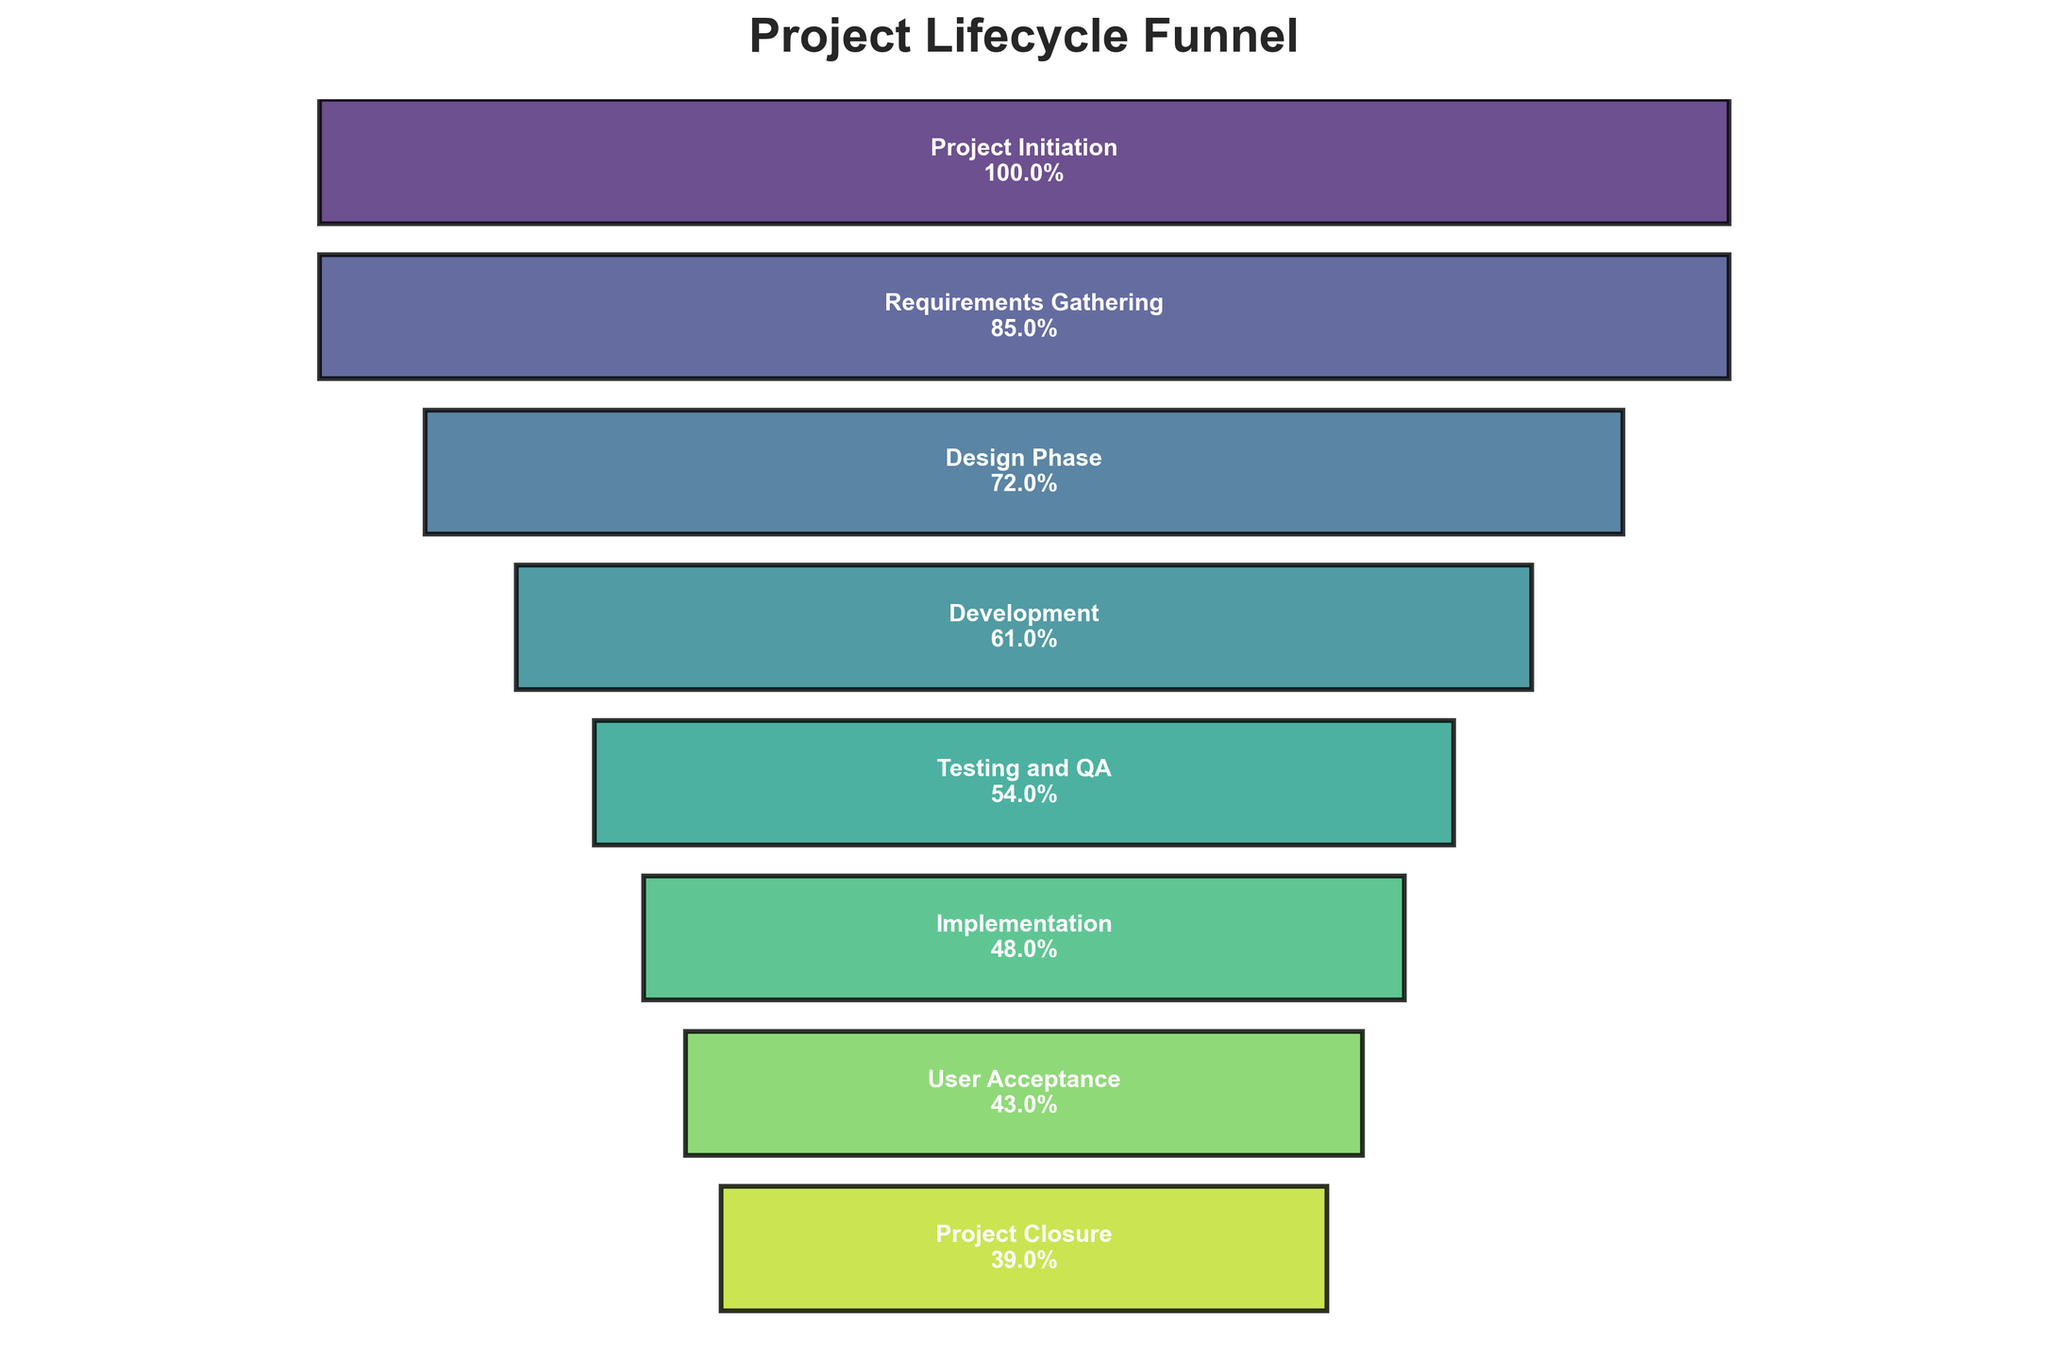How many stages are detailed in the Funnel Chart? The Funnel Chart has labels for each stage of the project lifecycle from initiation to closure. Counting these labels gives the total number of stages.
Answer: 8 What is the first stage in the project lifecycle? The Funnel Chart lists the stages from top to bottom. The first stage is at the top of the chart.
Answer: Project Initiation What's the difference in conversion rates between the 'Design Phase' and 'Development'? To find the difference, subtract the conversion rate of 'Development' from the 'Design Phase'. Conversion rates are 72% and 61%, respectively. So, 72% - 61% = 11%.
Answer: 11% Which stage has the lowest conversion rate? The Funnel Chart lists the conversion rate for each stage. The lowest rate is the last value listed.
Answer: Project Closure How many stages retain more than half of the initial conversion rate? Identify the stages with conversion rates greater than 50%. The stages are 'Project Initiation', 'Requirements Gathering', 'Design Phase', 'Development', and 'Testing and QA'. Count these stages.
Answer: 5 What's the average conversion rate from 'Requirements Gathering' to 'Implementation'? Add the conversion rates for ‘Requirements Gathering’ (85%), ‘Design Phase’ (72%), ‘Development’ (61%), ‘Testing and QA’ (54%), and ‘Implementation’ (48%), then divide by 5. The sum is 85 + 72 + 61 + 54 + 48 = 320, and the average is 320 / 5 = 64%.
Answer: 64% Compare the conversion rate drop from 'Testing and QA' to 'Implementation' with the drop from 'Implementation' to 'User Acceptance'. Which is greater? The drop from 'Testing and QA' (54%) to 'Implementation' (48%) is 54% - 48% = 6%. The drop from 'Implementation' (48%) to 'User Acceptance' (43%) is 48% - 43% = 5%. The greater drop is from 'Testing and QA' to 'Implementation'.
Answer: Testing and QA to Implementation What is the total decrease in conversion rate from 'Project Initiation' to 'Project Closure'? Subtract the conversion rate of 'Project Closure' from 'Project Initiation'. The rates are 100% and 39%, respectively. So, 100% - 39% = 61%.
Answer: 61% What is the median conversion rate of the stages? Organize the rates: 39%, 43%, 48%, 54%, 61%, 72%, 85%, 100%. The median is the average of the 4th and 5th values in an ordered list of eight numbers: (54% + 61%) / 2 = 57.5%.
Answer: 57.5% At which stage do more than 50% of the projects get filtered out for the first time? Identify the stage where the conversion rate drops below 50% for the first time. This occurs at the 'Implementation' stage with a rate of 48%, as 'Testing and QA' is at 54%.
Answer: Implementation 